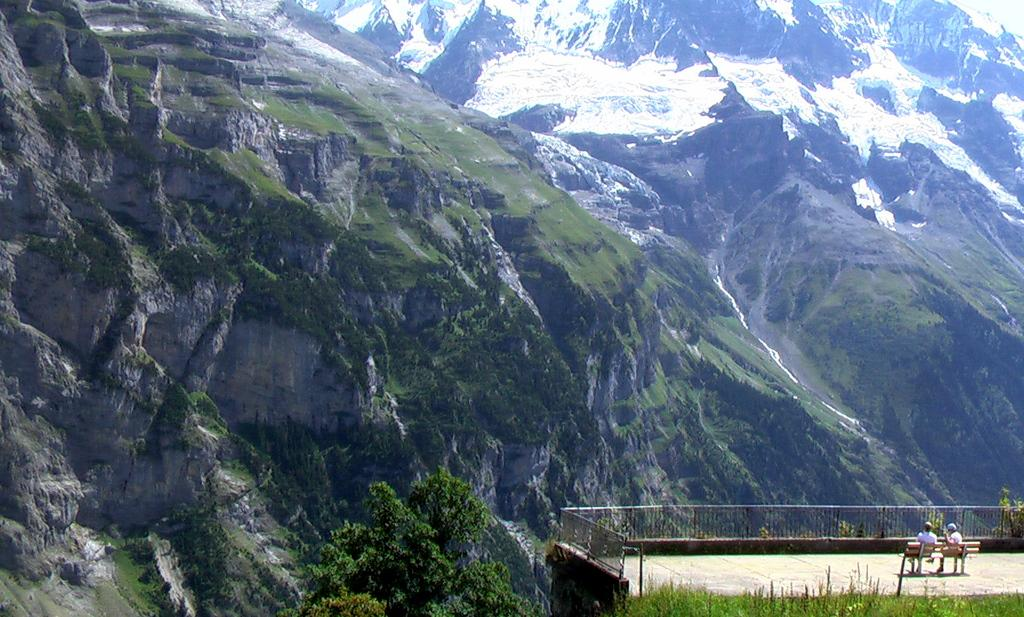How many people are sitting on the bench in the image? There are two people sitting on the bench in the image. What is in front of the bench? There is a railing in front of the bench. What type of vegetation can be seen in the image? There are trees and grass visible in the image. What type of landscape is visible in the background? There are mountains visible in the image. What type of haircut does the person on the left have in the image? There is no information about the people's haircuts in the image, as the focus is on their presence on the bench and the surrounding environment. 